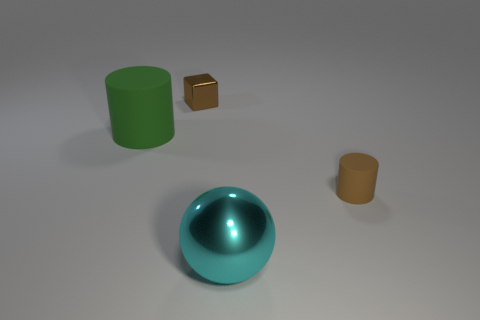Are there any other things that are the same shape as the brown metal thing?
Your response must be concise. No. There is a thing that is on the left side of the small brown matte cylinder and on the right side of the metal cube; what is its shape?
Keep it short and to the point. Sphere. What color is the object behind the large thing that is behind the tiny brown cylinder that is right of the big cyan object?
Provide a succinct answer. Brown. Are there fewer large cyan metal things on the right side of the big cyan ball than big red rubber objects?
Provide a succinct answer. No. There is a thing that is to the right of the cyan metal ball; does it have the same shape as the big object that is behind the brown rubber cylinder?
Offer a very short reply. Yes. How many objects are small objects on the left side of the metal sphere or small rubber things?
Keep it short and to the point. 2. There is a object that is the same color as the metallic cube; what is it made of?
Provide a succinct answer. Rubber. Are there any tiny matte things that are in front of the rubber cylinder that is on the left side of the brown thing to the right of the brown shiny block?
Give a very brief answer. Yes. Are there fewer big cylinders that are on the right side of the ball than cubes to the right of the green matte cylinder?
Offer a very short reply. Yes. What is the color of the thing that is made of the same material as the big sphere?
Your response must be concise. Brown. 